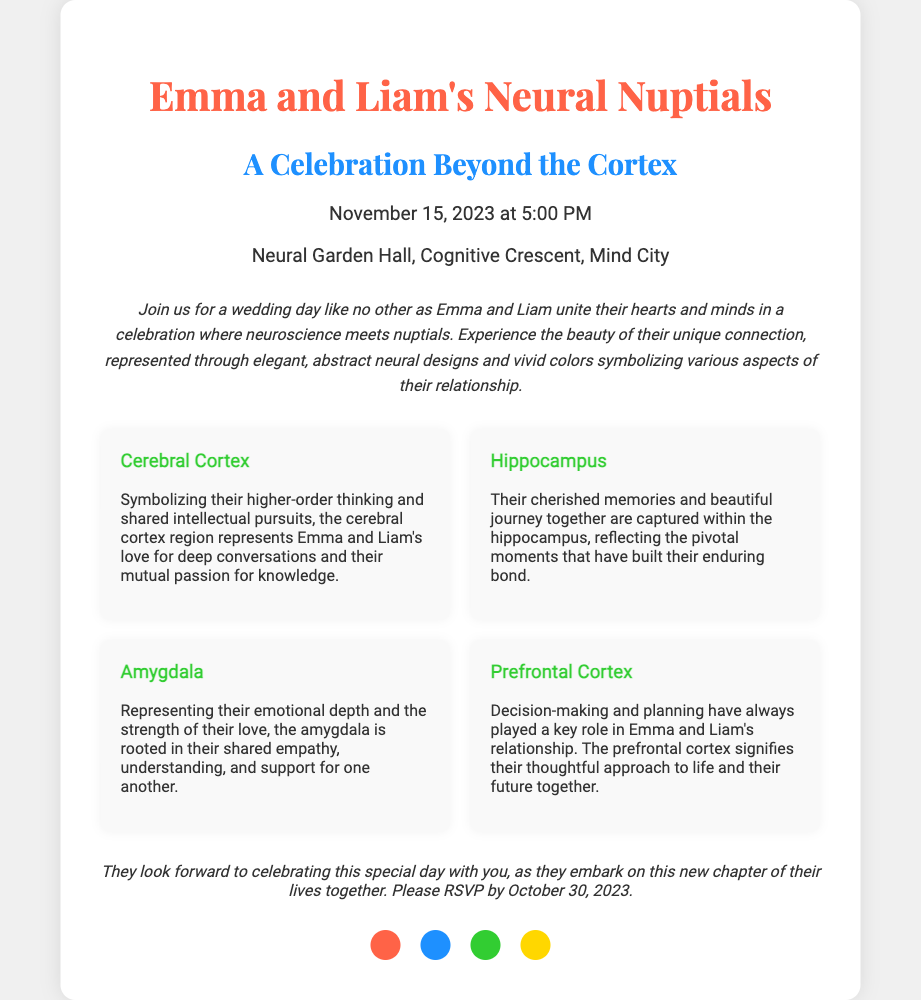What is the date of the wedding? The date of the wedding is clearly stated in the document, which is November 15, 2023.
Answer: November 15, 2023 Where is the wedding ceremony taking place? The venue for the wedding ceremony is mentioned in the invitation, which is Neural Garden Hall, Cognitive Crescent, Mind City.
Answer: Neural Garden Hall, Cognitive Crescent, Mind City What region represents their emotional depth? The document provides a specific region that symbolizes Emma and Liam's emotional depth, which is the Amygdala.
Answer: Amygdala What does the Prefrontal Cortex signify in their relationship? The Prefrontal Cortex is described in the document as signifying their thoughtful approach to life and their future together.
Answer: Thoughtful approach to life and future together By when should guests RSVP? The invitation specifies a deadline for RSVP, which is by October 30, 2023.
Answer: October 30, 2023 What color symbolizes passion and love in the design? The invitation includes a color palette, and the color representing passion and love is identified as #FF6347.
Answer: #FF6347 How many brain regions are highlighted in the invitation? The document lists specific brain regions representing aspects of their relationship, totaling four regions highlighted.
Answer: Four What is the purpose of the invitation? The purpose of the invitation is explicitly stated as a wedding day celebration where Emma and Liam unite their hearts and minds.
Answer: Wedding day celebration 